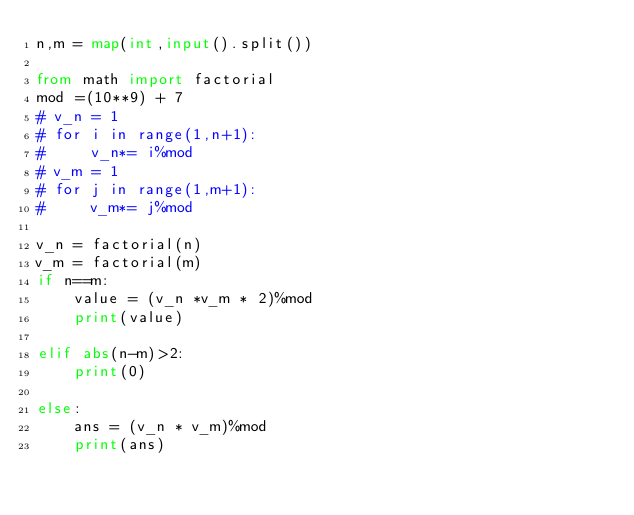<code> <loc_0><loc_0><loc_500><loc_500><_Python_>n,m = map(int,input().split())

from math import factorial
mod =(10**9) + 7
# v_n = 1
# for i in range(1,n+1):
#     v_n*= i%mod
# v_m = 1
# for j in range(1,m+1):
#     v_m*= j%mod

v_n = factorial(n)
v_m = factorial(m)
if n==m:
    value = (v_n *v_m * 2)%mod
    print(value)

elif abs(n-m)>2:
    print(0)

else:
    ans = (v_n * v_m)%mod
    print(ans)</code> 